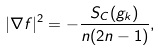Convert formula to latex. <formula><loc_0><loc_0><loc_500><loc_500>| \nabla f | ^ { 2 } = - \frac { S _ { C } ( g _ { k } ) } { n ( 2 n - 1 ) } ,</formula> 